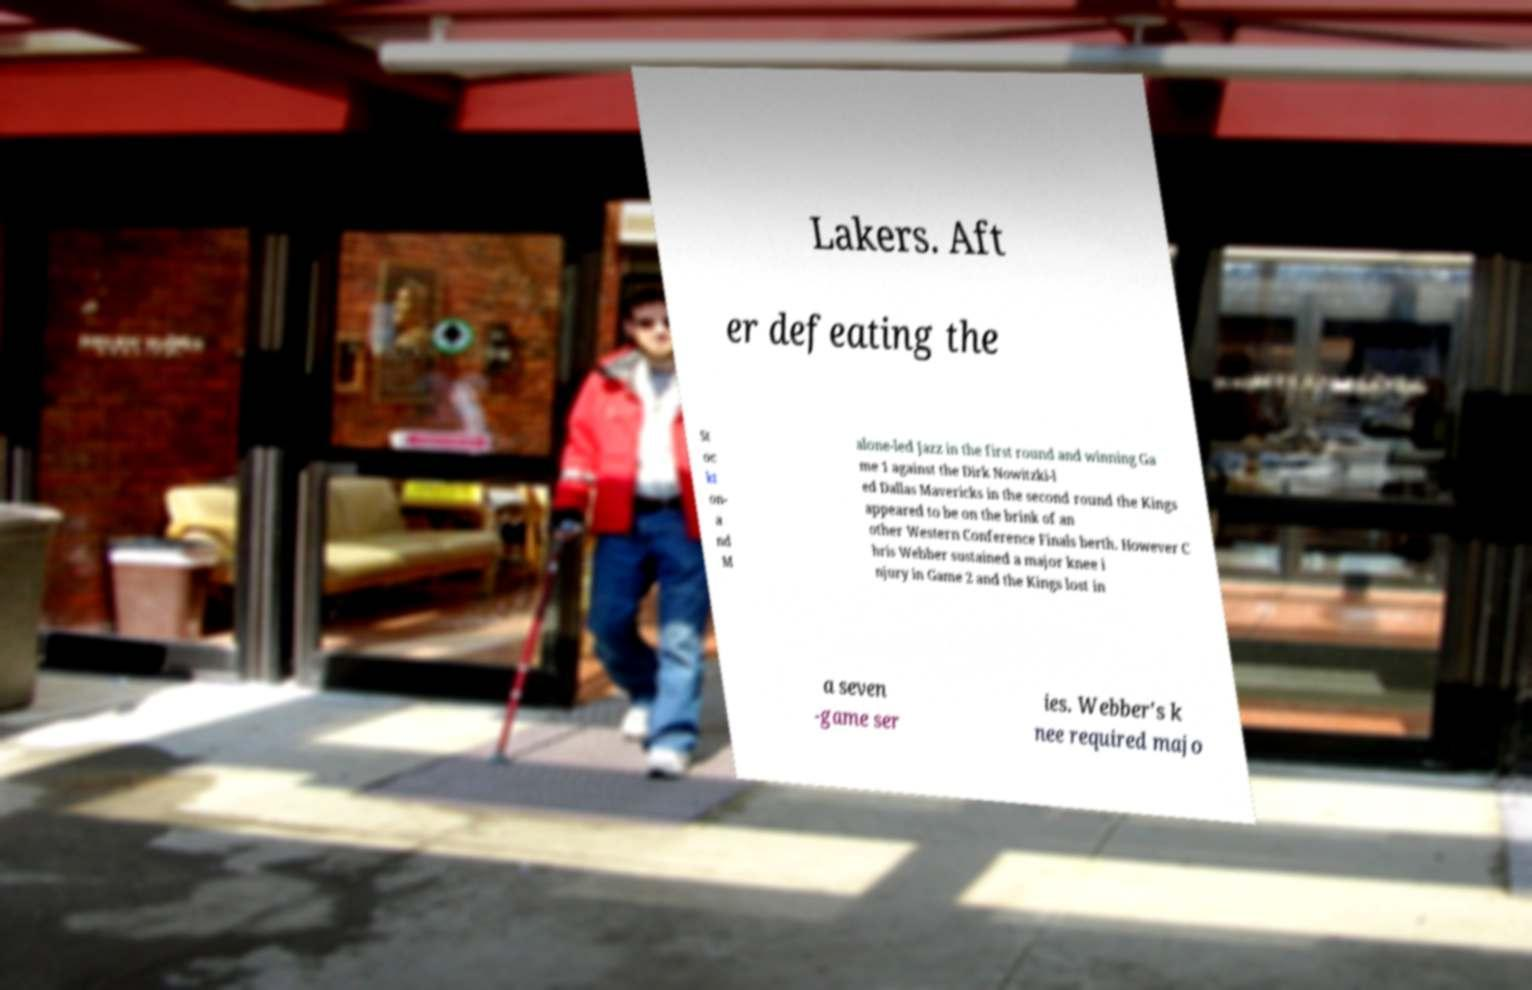For documentation purposes, I need the text within this image transcribed. Could you provide that? Lakers. Aft er defeating the St oc kt on- a nd M alone-led Jazz in the first round and winning Ga me 1 against the Dirk Nowitzki-l ed Dallas Mavericks in the second round the Kings appeared to be on the brink of an other Western Conference Finals berth. However C hris Webber sustained a major knee i njury in Game 2 and the Kings lost in a seven -game ser ies. Webber's k nee required majo 